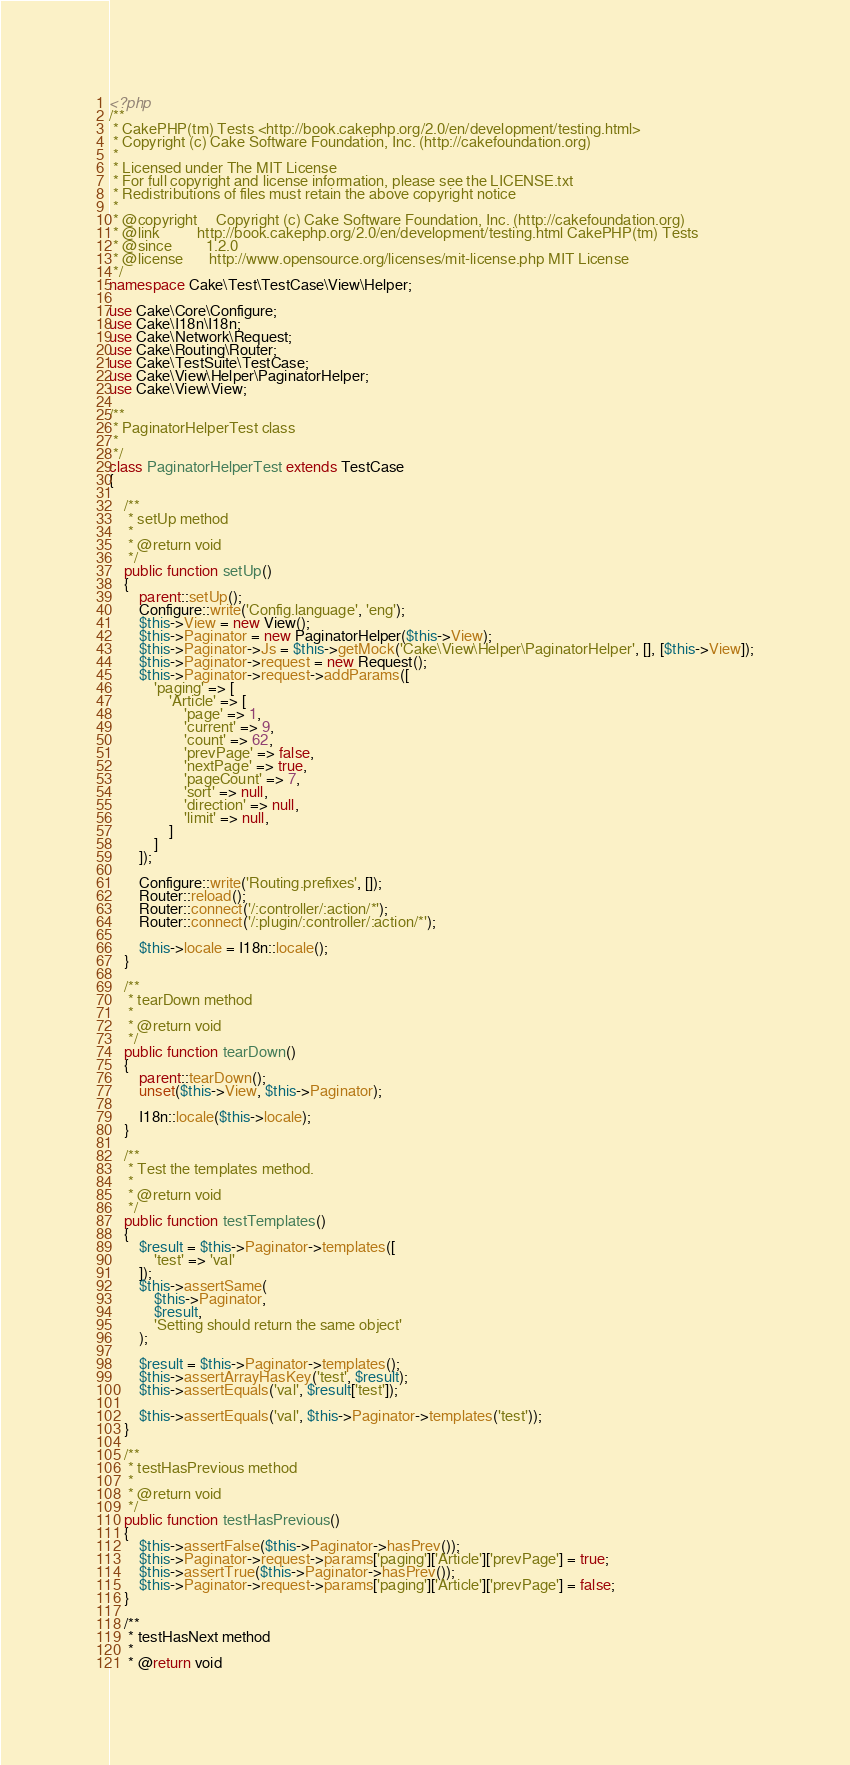Convert code to text. <code><loc_0><loc_0><loc_500><loc_500><_PHP_><?php
/**
 * CakePHP(tm) Tests <http://book.cakephp.org/2.0/en/development/testing.html>
 * Copyright (c) Cake Software Foundation, Inc. (http://cakefoundation.org)
 *
 * Licensed under The MIT License
 * For full copyright and license information, please see the LICENSE.txt
 * Redistributions of files must retain the above copyright notice
 *
 * @copyright     Copyright (c) Cake Software Foundation, Inc. (http://cakefoundation.org)
 * @link          http://book.cakephp.org/2.0/en/development/testing.html CakePHP(tm) Tests
 * @since         1.2.0
 * @license       http://www.opensource.org/licenses/mit-license.php MIT License
 */
namespace Cake\Test\TestCase\View\Helper;

use Cake\Core\Configure;
use Cake\I18n\I18n;
use Cake\Network\Request;
use Cake\Routing\Router;
use Cake\TestSuite\TestCase;
use Cake\View\Helper\PaginatorHelper;
use Cake\View\View;

/**
 * PaginatorHelperTest class
 *
 */
class PaginatorHelperTest extends TestCase
{

    /**
     * setUp method
     *
     * @return void
     */
    public function setUp()
    {
        parent::setUp();
        Configure::write('Config.language', 'eng');
        $this->View = new View();
        $this->Paginator = new PaginatorHelper($this->View);
        $this->Paginator->Js = $this->getMock('Cake\View\Helper\PaginatorHelper', [], [$this->View]);
        $this->Paginator->request = new Request();
        $this->Paginator->request->addParams([
            'paging' => [
                'Article' => [
                    'page' => 1,
                    'current' => 9,
                    'count' => 62,
                    'prevPage' => false,
                    'nextPage' => true,
                    'pageCount' => 7,
                    'sort' => null,
                    'direction' => null,
                    'limit' => null,
                ]
            ]
        ]);

        Configure::write('Routing.prefixes', []);
        Router::reload();
        Router::connect('/:controller/:action/*');
        Router::connect('/:plugin/:controller/:action/*');

        $this->locale = I18n::locale();
    }

    /**
     * tearDown method
     *
     * @return void
     */
    public function tearDown()
    {
        parent::tearDown();
        unset($this->View, $this->Paginator);

        I18n::locale($this->locale);
    }

    /**
     * Test the templates method.
     *
     * @return void
     */
    public function testTemplates()
    {
        $result = $this->Paginator->templates([
            'test' => 'val'
        ]);
        $this->assertSame(
            $this->Paginator,
            $result,
            'Setting should return the same object'
        );

        $result = $this->Paginator->templates();
        $this->assertArrayHasKey('test', $result);
        $this->assertEquals('val', $result['test']);

        $this->assertEquals('val', $this->Paginator->templates('test'));
    }

    /**
     * testHasPrevious method
     *
     * @return void
     */
    public function testHasPrevious()
    {
        $this->assertFalse($this->Paginator->hasPrev());
        $this->Paginator->request->params['paging']['Article']['prevPage'] = true;
        $this->assertTrue($this->Paginator->hasPrev());
        $this->Paginator->request->params['paging']['Article']['prevPage'] = false;
    }

    /**
     * testHasNext method
     *
     * @return void</code> 